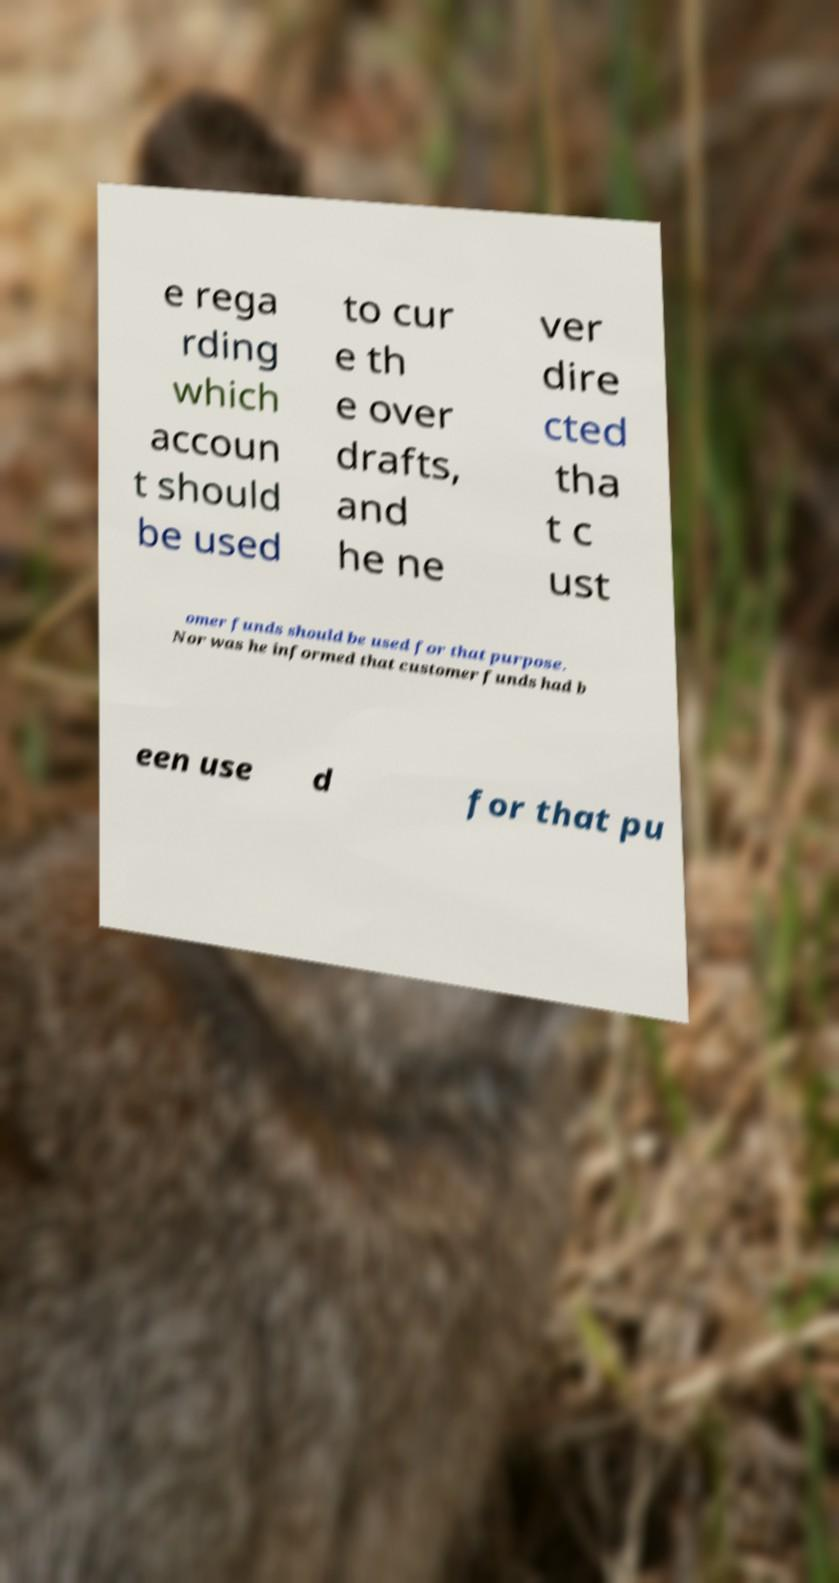I need the written content from this picture converted into text. Can you do that? e rega rding which accoun t should be used to cur e th e over drafts, and he ne ver dire cted tha t c ust omer funds should be used for that purpose. Nor was he informed that customer funds had b een use d for that pu 